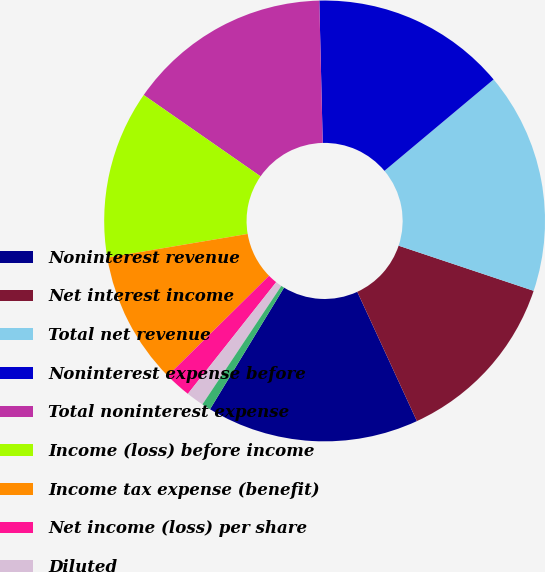Convert chart. <chart><loc_0><loc_0><loc_500><loc_500><pie_chart><fcel>Noninterest revenue<fcel>Net interest income<fcel>Total net revenue<fcel>Noninterest expense before<fcel>Total noninterest expense<fcel>Income (loss) before income<fcel>Income tax expense (benefit)<fcel>Net income (loss) per share<fcel>Diluted<fcel>Cash dividends declared per<nl><fcel>15.58%<fcel>12.99%<fcel>16.23%<fcel>14.29%<fcel>14.94%<fcel>12.34%<fcel>9.74%<fcel>1.95%<fcel>1.3%<fcel>0.65%<nl></chart> 